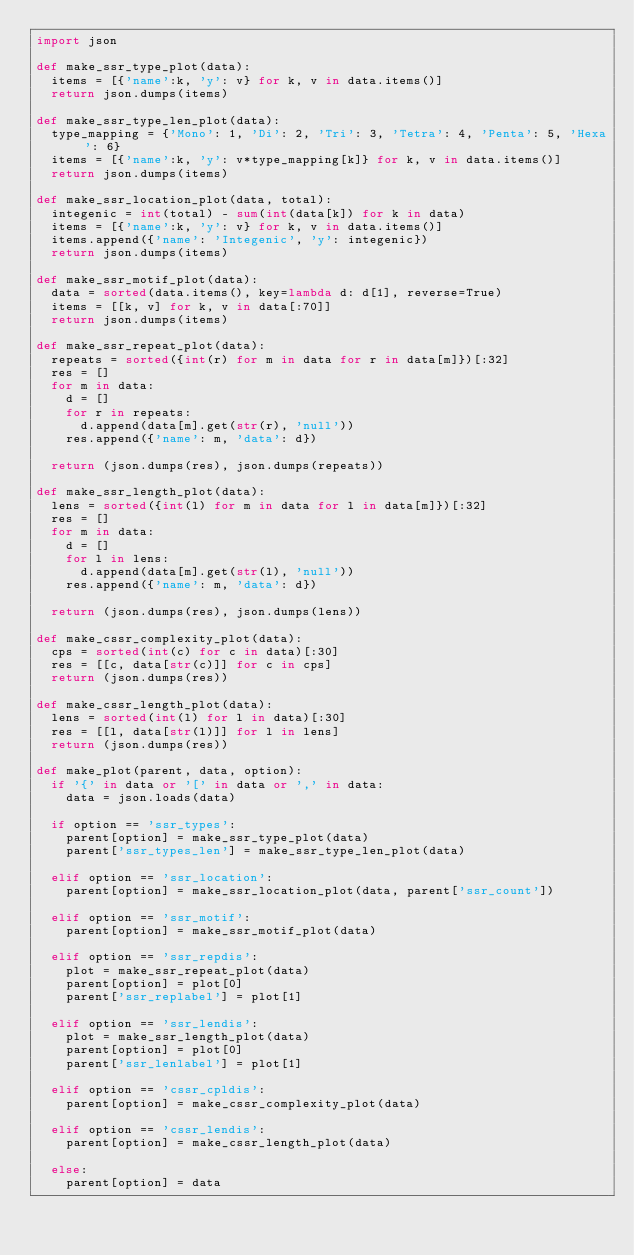<code> <loc_0><loc_0><loc_500><loc_500><_Python_>import json

def make_ssr_type_plot(data):
	items = [{'name':k, 'y': v} for k, v in data.items()]
	return json.dumps(items)

def make_ssr_type_len_plot(data):
	type_mapping = {'Mono': 1, 'Di': 2, 'Tri': 3, 'Tetra': 4, 'Penta': 5, 'Hexa': 6}
	items = [{'name':k, 'y': v*type_mapping[k]} for k, v in data.items()]
	return json.dumps(items)

def make_ssr_location_plot(data, total):
	integenic = int(total) - sum(int(data[k]) for k in data)
	items = [{'name':k, 'y': v} for k, v in data.items()]
	items.append({'name': 'Integenic', 'y': integenic})
	return json.dumps(items)

def make_ssr_motif_plot(data):
	data = sorted(data.items(), key=lambda d: d[1], reverse=True)
	items = [[k, v] for k, v in data[:70]]
	return json.dumps(items)

def make_ssr_repeat_plot(data):
	repeats = sorted({int(r) for m in data for r in data[m]})[:32]
	res = []
	for m in data:
		d = []
		for r in repeats:
			d.append(data[m].get(str(r), 'null'))
		res.append({'name': m, 'data': d})

	return (json.dumps(res), json.dumps(repeats))

def make_ssr_length_plot(data):
	lens = sorted({int(l) for m in data for l in data[m]})[:32]
	res = []
	for m in data:
		d = []
		for l in lens:
			d.append(data[m].get(str(l), 'null'))
		res.append({'name': m, 'data': d})

	return (json.dumps(res), json.dumps(lens))

def make_cssr_complexity_plot(data):
	cps = sorted(int(c) for c in data)[:30]
	res = [[c, data[str(c)]] for c in cps]
	return (json.dumps(res))
	
def make_cssr_length_plot(data):
	lens = sorted(int(l) for l in data)[:30]
	res = [[l, data[str(l)]] for l in lens]
	return (json.dumps(res))

def make_plot(parent, data, option):
	if '{' in data or '[' in data or ',' in data:
		data = json.loads(data)

	if option == 'ssr_types':
		parent[option] = make_ssr_type_plot(data)
		parent['ssr_types_len'] = make_ssr_type_len_plot(data)

	elif option == 'ssr_location':
		parent[option] = make_ssr_location_plot(data, parent['ssr_count'])
	
	elif option == 'ssr_motif':
		parent[option] = make_ssr_motif_plot(data)

	elif option == 'ssr_repdis':
		plot = make_ssr_repeat_plot(data)
		parent[option] = plot[0]
		parent['ssr_replabel'] = plot[1]

	elif option == 'ssr_lendis':
		plot = make_ssr_length_plot(data)
		parent[option] = plot[0]
		parent['ssr_lenlabel'] = plot[1]

	elif option == 'cssr_cpldis':
		parent[option] = make_cssr_complexity_plot(data)

	elif option == 'cssr_lendis':
		parent[option] = make_cssr_length_plot(data)

	else:
		parent[option] = data

</code> 